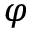Convert formula to latex. <formula><loc_0><loc_0><loc_500><loc_500>\varphi</formula> 